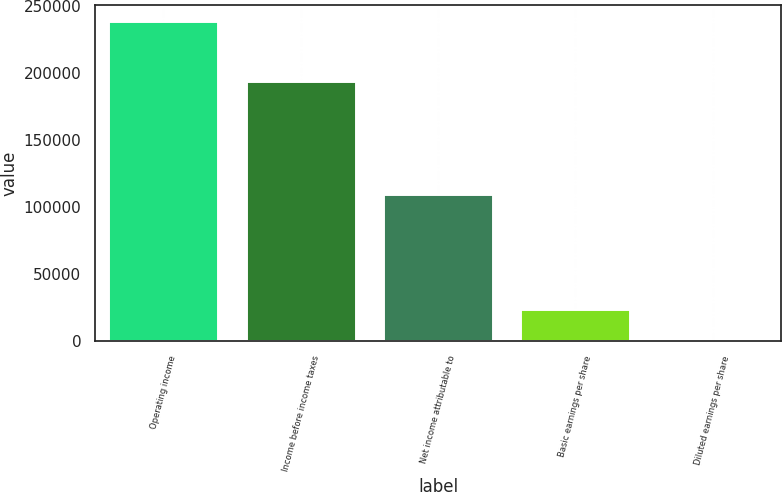<chart> <loc_0><loc_0><loc_500><loc_500><bar_chart><fcel>Operating income<fcel>Income before income taxes<fcel>Net income attributable to<fcel>Basic earnings per share<fcel>Diluted earnings per share<nl><fcel>238712<fcel>194563<fcel>109724<fcel>23872.2<fcel>1.06<nl></chart> 